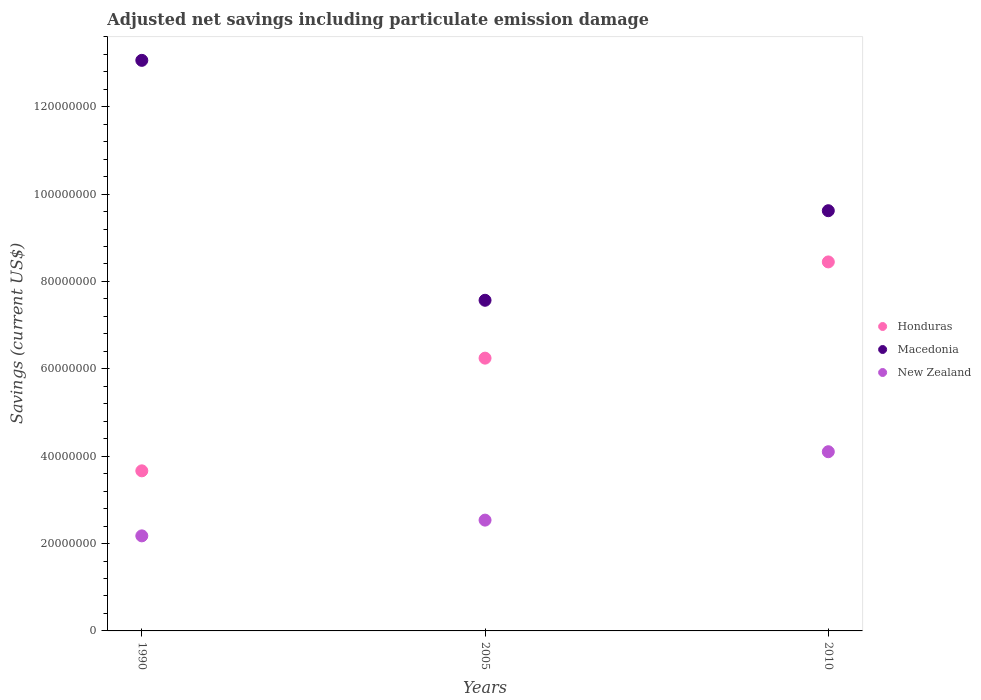What is the net savings in Honduras in 1990?
Make the answer very short. 3.66e+07. Across all years, what is the maximum net savings in Honduras?
Your answer should be very brief. 8.45e+07. Across all years, what is the minimum net savings in Macedonia?
Provide a short and direct response. 7.57e+07. What is the total net savings in Honduras in the graph?
Ensure brevity in your answer.  1.84e+08. What is the difference between the net savings in New Zealand in 1990 and that in 2010?
Make the answer very short. -1.93e+07. What is the difference between the net savings in New Zealand in 2005 and the net savings in Honduras in 1990?
Ensure brevity in your answer.  -1.13e+07. What is the average net savings in New Zealand per year?
Provide a short and direct response. 2.94e+07. In the year 2005, what is the difference between the net savings in New Zealand and net savings in Macedonia?
Offer a terse response. -5.03e+07. In how many years, is the net savings in Honduras greater than 36000000 US$?
Offer a terse response. 3. What is the ratio of the net savings in Honduras in 1990 to that in 2010?
Provide a short and direct response. 0.43. Is the net savings in New Zealand in 2005 less than that in 2010?
Keep it short and to the point. Yes. What is the difference between the highest and the second highest net savings in Honduras?
Make the answer very short. 2.20e+07. What is the difference between the highest and the lowest net savings in New Zealand?
Your response must be concise. 1.93e+07. Does the net savings in Macedonia monotonically increase over the years?
Keep it short and to the point. No. Is the net savings in New Zealand strictly less than the net savings in Macedonia over the years?
Offer a very short reply. Yes. How many dotlines are there?
Ensure brevity in your answer.  3. How many years are there in the graph?
Ensure brevity in your answer.  3. Does the graph contain grids?
Your answer should be very brief. No. Where does the legend appear in the graph?
Provide a succinct answer. Center right. How are the legend labels stacked?
Keep it short and to the point. Vertical. What is the title of the graph?
Ensure brevity in your answer.  Adjusted net savings including particulate emission damage. Does "Saudi Arabia" appear as one of the legend labels in the graph?
Make the answer very short. No. What is the label or title of the Y-axis?
Offer a terse response. Savings (current US$). What is the Savings (current US$) in Honduras in 1990?
Provide a succinct answer. 3.66e+07. What is the Savings (current US$) of Macedonia in 1990?
Keep it short and to the point. 1.31e+08. What is the Savings (current US$) in New Zealand in 1990?
Make the answer very short. 2.18e+07. What is the Savings (current US$) in Honduras in 2005?
Offer a very short reply. 6.24e+07. What is the Savings (current US$) of Macedonia in 2005?
Your answer should be very brief. 7.57e+07. What is the Savings (current US$) in New Zealand in 2005?
Provide a succinct answer. 2.54e+07. What is the Savings (current US$) of Honduras in 2010?
Your answer should be very brief. 8.45e+07. What is the Savings (current US$) of Macedonia in 2010?
Your response must be concise. 9.62e+07. What is the Savings (current US$) in New Zealand in 2010?
Offer a terse response. 4.10e+07. Across all years, what is the maximum Savings (current US$) in Honduras?
Your answer should be very brief. 8.45e+07. Across all years, what is the maximum Savings (current US$) of Macedonia?
Your answer should be very brief. 1.31e+08. Across all years, what is the maximum Savings (current US$) in New Zealand?
Provide a succinct answer. 4.10e+07. Across all years, what is the minimum Savings (current US$) of Honduras?
Your answer should be compact. 3.66e+07. Across all years, what is the minimum Savings (current US$) of Macedonia?
Keep it short and to the point. 7.57e+07. Across all years, what is the minimum Savings (current US$) in New Zealand?
Your response must be concise. 2.18e+07. What is the total Savings (current US$) in Honduras in the graph?
Offer a terse response. 1.84e+08. What is the total Savings (current US$) of Macedonia in the graph?
Provide a short and direct response. 3.03e+08. What is the total Savings (current US$) of New Zealand in the graph?
Your answer should be compact. 8.81e+07. What is the difference between the Savings (current US$) of Honduras in 1990 and that in 2005?
Your answer should be very brief. -2.58e+07. What is the difference between the Savings (current US$) in Macedonia in 1990 and that in 2005?
Give a very brief answer. 5.49e+07. What is the difference between the Savings (current US$) in New Zealand in 1990 and that in 2005?
Your response must be concise. -3.60e+06. What is the difference between the Savings (current US$) of Honduras in 1990 and that in 2010?
Your answer should be compact. -4.78e+07. What is the difference between the Savings (current US$) of Macedonia in 1990 and that in 2010?
Offer a terse response. 3.44e+07. What is the difference between the Savings (current US$) in New Zealand in 1990 and that in 2010?
Give a very brief answer. -1.93e+07. What is the difference between the Savings (current US$) in Honduras in 2005 and that in 2010?
Make the answer very short. -2.20e+07. What is the difference between the Savings (current US$) in Macedonia in 2005 and that in 2010?
Make the answer very short. -2.05e+07. What is the difference between the Savings (current US$) of New Zealand in 2005 and that in 2010?
Your answer should be very brief. -1.57e+07. What is the difference between the Savings (current US$) of Honduras in 1990 and the Savings (current US$) of Macedonia in 2005?
Give a very brief answer. -3.90e+07. What is the difference between the Savings (current US$) of Honduras in 1990 and the Savings (current US$) of New Zealand in 2005?
Make the answer very short. 1.13e+07. What is the difference between the Savings (current US$) of Macedonia in 1990 and the Savings (current US$) of New Zealand in 2005?
Make the answer very short. 1.05e+08. What is the difference between the Savings (current US$) in Honduras in 1990 and the Savings (current US$) in Macedonia in 2010?
Provide a succinct answer. -5.95e+07. What is the difference between the Savings (current US$) in Honduras in 1990 and the Savings (current US$) in New Zealand in 2010?
Give a very brief answer. -4.38e+06. What is the difference between the Savings (current US$) of Macedonia in 1990 and the Savings (current US$) of New Zealand in 2010?
Provide a succinct answer. 8.96e+07. What is the difference between the Savings (current US$) of Honduras in 2005 and the Savings (current US$) of Macedonia in 2010?
Ensure brevity in your answer.  -3.38e+07. What is the difference between the Savings (current US$) of Honduras in 2005 and the Savings (current US$) of New Zealand in 2010?
Provide a short and direct response. 2.14e+07. What is the difference between the Savings (current US$) in Macedonia in 2005 and the Savings (current US$) in New Zealand in 2010?
Make the answer very short. 3.47e+07. What is the average Savings (current US$) of Honduras per year?
Make the answer very short. 6.12e+07. What is the average Savings (current US$) of Macedonia per year?
Keep it short and to the point. 1.01e+08. What is the average Savings (current US$) in New Zealand per year?
Offer a very short reply. 2.94e+07. In the year 1990, what is the difference between the Savings (current US$) of Honduras and Savings (current US$) of Macedonia?
Your response must be concise. -9.40e+07. In the year 1990, what is the difference between the Savings (current US$) in Honduras and Savings (current US$) in New Zealand?
Provide a short and direct response. 1.49e+07. In the year 1990, what is the difference between the Savings (current US$) in Macedonia and Savings (current US$) in New Zealand?
Keep it short and to the point. 1.09e+08. In the year 2005, what is the difference between the Savings (current US$) of Honduras and Savings (current US$) of Macedonia?
Give a very brief answer. -1.32e+07. In the year 2005, what is the difference between the Savings (current US$) of Honduras and Savings (current US$) of New Zealand?
Provide a succinct answer. 3.71e+07. In the year 2005, what is the difference between the Savings (current US$) of Macedonia and Savings (current US$) of New Zealand?
Your response must be concise. 5.03e+07. In the year 2010, what is the difference between the Savings (current US$) of Honduras and Savings (current US$) of Macedonia?
Your answer should be compact. -1.17e+07. In the year 2010, what is the difference between the Savings (current US$) of Honduras and Savings (current US$) of New Zealand?
Offer a terse response. 4.35e+07. In the year 2010, what is the difference between the Savings (current US$) of Macedonia and Savings (current US$) of New Zealand?
Provide a short and direct response. 5.52e+07. What is the ratio of the Savings (current US$) of Honduras in 1990 to that in 2005?
Your response must be concise. 0.59. What is the ratio of the Savings (current US$) of Macedonia in 1990 to that in 2005?
Give a very brief answer. 1.73. What is the ratio of the Savings (current US$) of New Zealand in 1990 to that in 2005?
Ensure brevity in your answer.  0.86. What is the ratio of the Savings (current US$) in Honduras in 1990 to that in 2010?
Ensure brevity in your answer.  0.43. What is the ratio of the Savings (current US$) of Macedonia in 1990 to that in 2010?
Offer a very short reply. 1.36. What is the ratio of the Savings (current US$) in New Zealand in 1990 to that in 2010?
Your answer should be very brief. 0.53. What is the ratio of the Savings (current US$) of Honduras in 2005 to that in 2010?
Ensure brevity in your answer.  0.74. What is the ratio of the Savings (current US$) in Macedonia in 2005 to that in 2010?
Offer a very short reply. 0.79. What is the ratio of the Savings (current US$) in New Zealand in 2005 to that in 2010?
Provide a succinct answer. 0.62. What is the difference between the highest and the second highest Savings (current US$) of Honduras?
Offer a terse response. 2.20e+07. What is the difference between the highest and the second highest Savings (current US$) of Macedonia?
Your answer should be compact. 3.44e+07. What is the difference between the highest and the second highest Savings (current US$) of New Zealand?
Make the answer very short. 1.57e+07. What is the difference between the highest and the lowest Savings (current US$) of Honduras?
Offer a very short reply. 4.78e+07. What is the difference between the highest and the lowest Savings (current US$) of Macedonia?
Ensure brevity in your answer.  5.49e+07. What is the difference between the highest and the lowest Savings (current US$) of New Zealand?
Your answer should be very brief. 1.93e+07. 